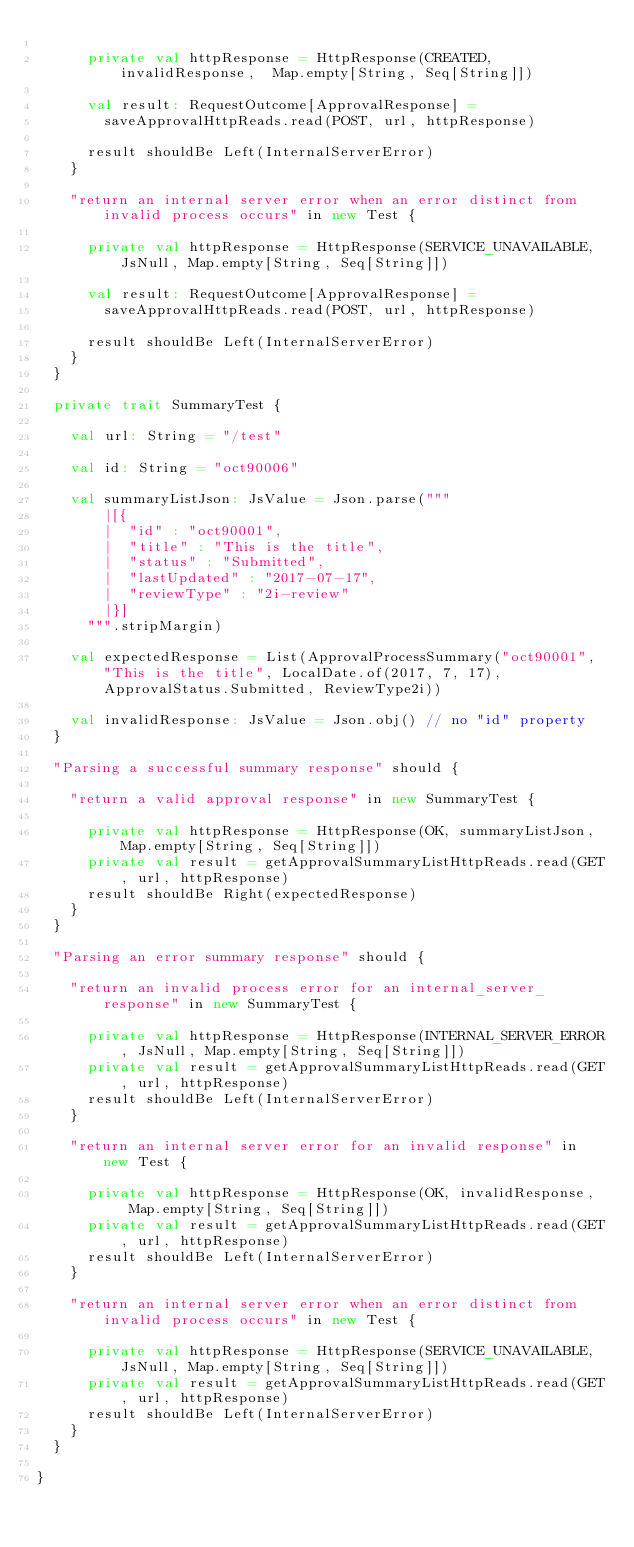Convert code to text. <code><loc_0><loc_0><loc_500><loc_500><_Scala_>
      private val httpResponse = HttpResponse(CREATED, invalidResponse,  Map.empty[String, Seq[String]])

      val result: RequestOutcome[ApprovalResponse] =
        saveApprovalHttpReads.read(POST, url, httpResponse)

      result shouldBe Left(InternalServerError)
    }

    "return an internal server error when an error distinct from invalid process occurs" in new Test {

      private val httpResponse = HttpResponse(SERVICE_UNAVAILABLE, JsNull, Map.empty[String, Seq[String]])

      val result: RequestOutcome[ApprovalResponse] =
        saveApprovalHttpReads.read(POST, url, httpResponse)

      result shouldBe Left(InternalServerError)
    }
  }

  private trait SummaryTest {

    val url: String = "/test"

    val id: String = "oct90006"

    val summaryListJson: JsValue = Json.parse("""
        |[{
        |  "id" : "oct90001",
        |  "title" : "This is the title",
        |  "status" : "Submitted",
        |  "lastUpdated" : "2017-07-17",
        |  "reviewType" : "2i-review"
        |}]
      """.stripMargin)

    val expectedResponse = List(ApprovalProcessSummary("oct90001", "This is the title", LocalDate.of(2017, 7, 17), ApprovalStatus.Submitted, ReviewType2i))

    val invalidResponse: JsValue = Json.obj() // no "id" property
  }

  "Parsing a successful summary response" should {

    "return a valid approval response" in new SummaryTest {

      private val httpResponse = HttpResponse(OK, summaryListJson, Map.empty[String, Seq[String]])
      private val result = getApprovalSummaryListHttpReads.read(GET, url, httpResponse)
      result shouldBe Right(expectedResponse)
    }
  }

  "Parsing an error summary response" should {

    "return an invalid process error for an internal_server_response" in new SummaryTest {

      private val httpResponse = HttpResponse(INTERNAL_SERVER_ERROR, JsNull, Map.empty[String, Seq[String]])
      private val result = getApprovalSummaryListHttpReads.read(GET, url, httpResponse)
      result shouldBe Left(InternalServerError)
    }

    "return an internal server error for an invalid response" in new Test {

      private val httpResponse = HttpResponse(OK, invalidResponse,  Map.empty[String, Seq[String]])
      private val result = getApprovalSummaryListHttpReads.read(GET, url, httpResponse)
      result shouldBe Left(InternalServerError)
    }

    "return an internal server error when an error distinct from invalid process occurs" in new Test {

      private val httpResponse = HttpResponse(SERVICE_UNAVAILABLE, JsNull, Map.empty[String, Seq[String]])
      private val result = getApprovalSummaryListHttpReads.read(GET, url, httpResponse)
      result shouldBe Left(InternalServerError)
    }
  }

}
</code> 